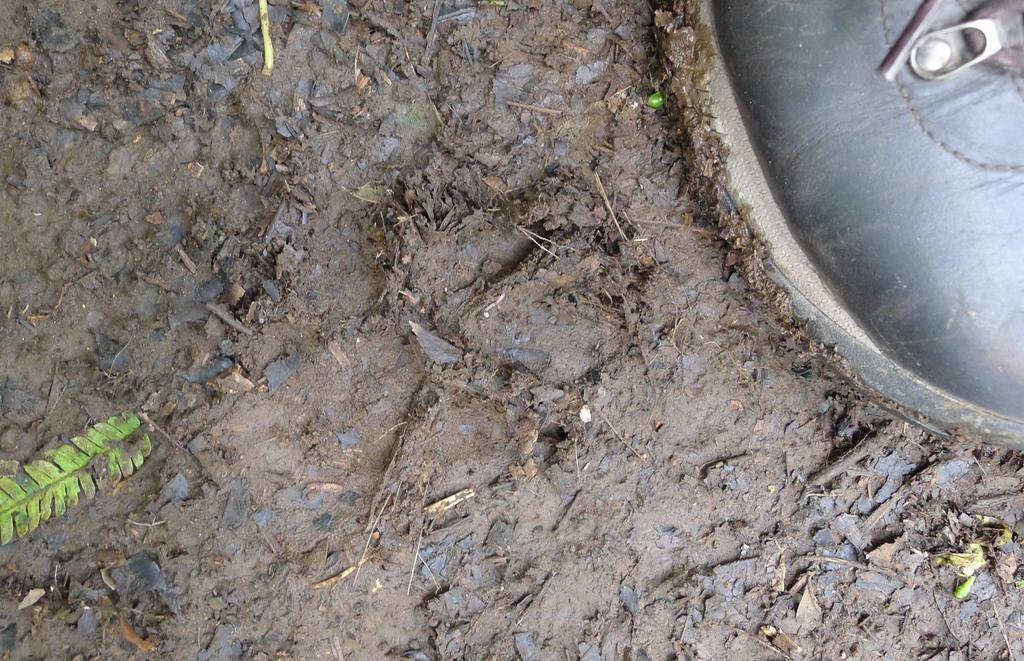Describe this image in one or two sentences. In the image we can see there is a ground which is covered with wet mud and there is a black colour shoe of a person. Its corners are covered with mud. 